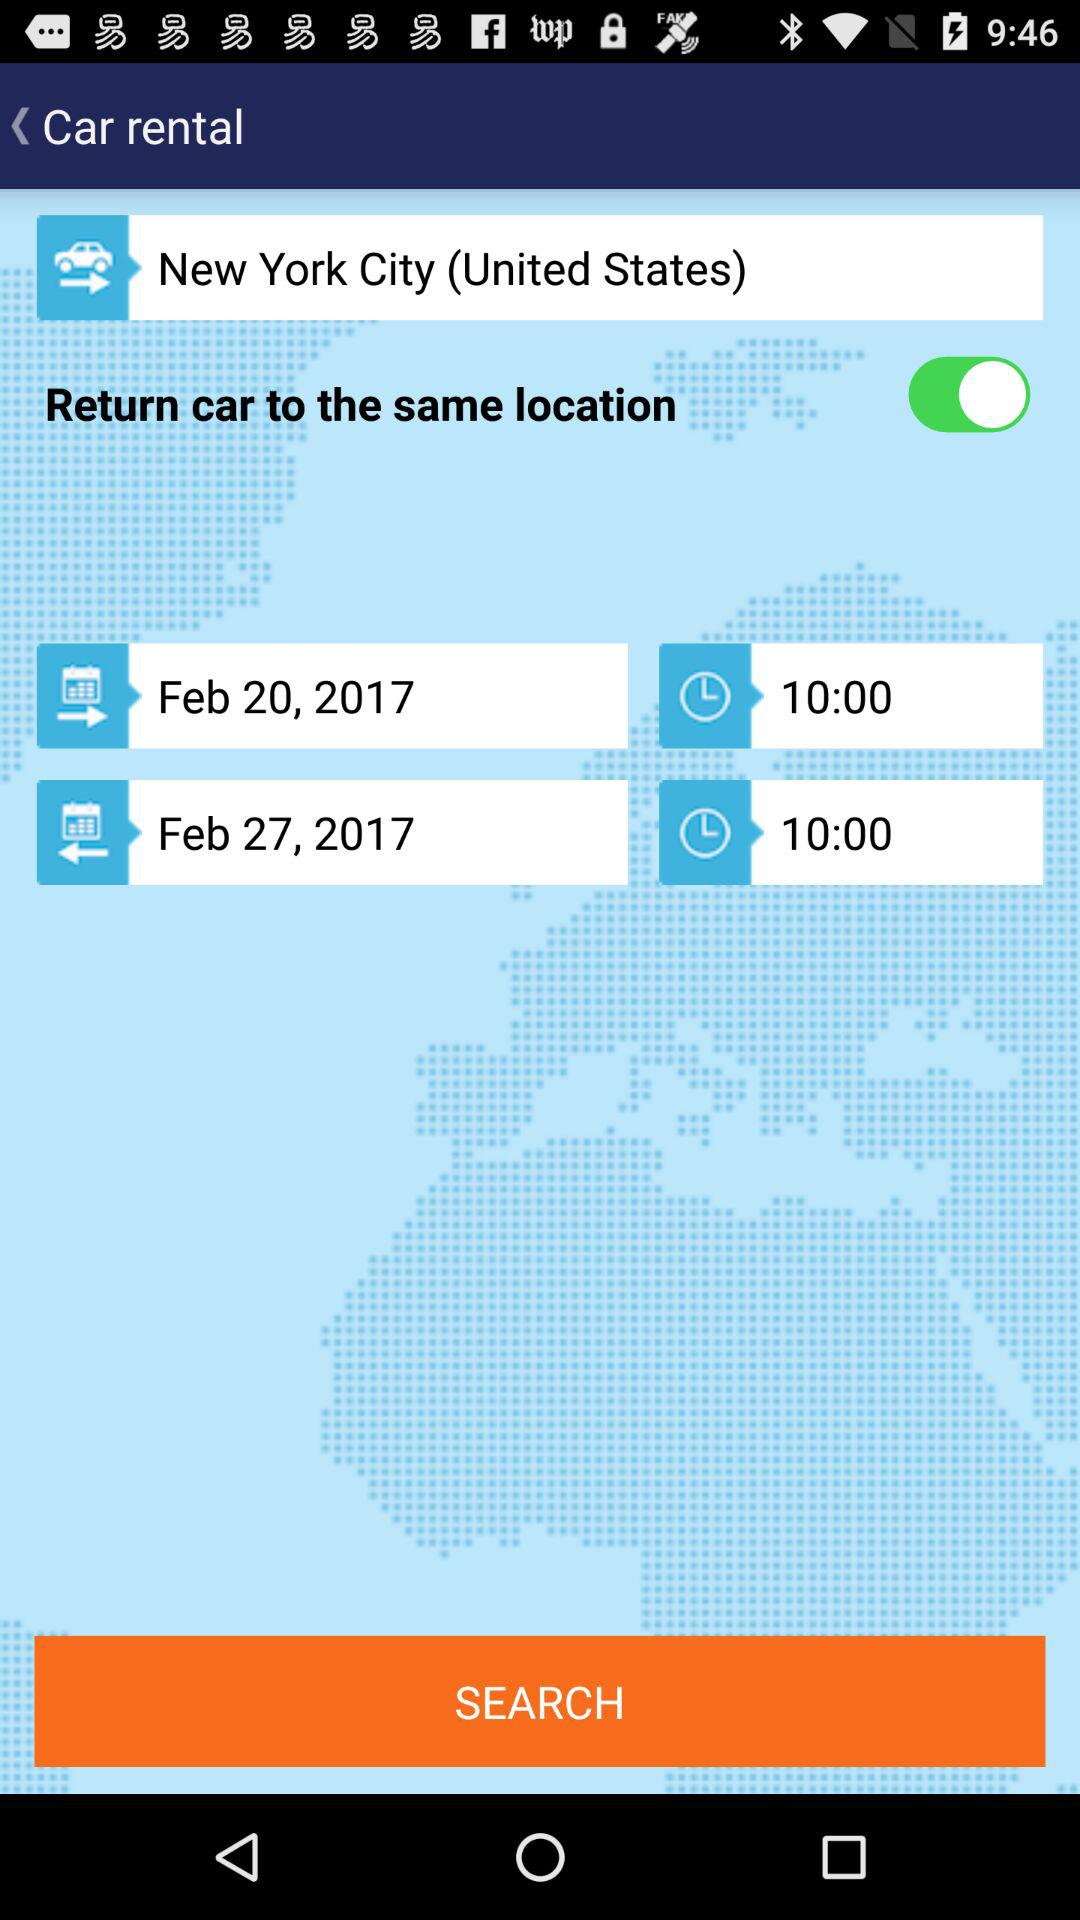What is the status of "Return car to the same location"? The status is "on". 